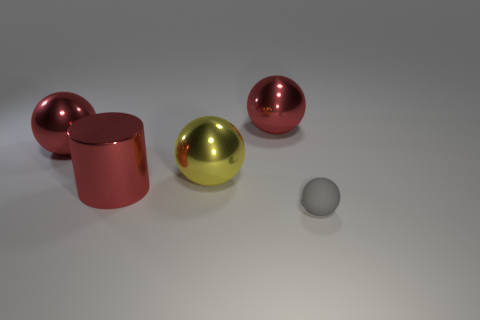Is there any other thing that is made of the same material as the small gray ball?
Offer a terse response. No. Are there any things that are in front of the thing behind the metallic thing that is to the left of the red metallic cylinder?
Keep it short and to the point. Yes. There is a yellow object that is the same size as the red shiny cylinder; what is its shape?
Give a very brief answer. Sphere. The other tiny object that is the same shape as the yellow metal object is what color?
Offer a very short reply. Gray. How many objects are either red balls or gray spheres?
Make the answer very short. 3. Do the large metal object that is right of the yellow shiny sphere and the thing that is to the left of the large cylinder have the same shape?
Offer a very short reply. Yes. There is a red metal thing that is in front of the yellow sphere; what shape is it?
Provide a short and direct response. Cylinder. Are there the same number of tiny objects in front of the yellow sphere and yellow things that are on the left side of the cylinder?
Give a very brief answer. No. How many things are tiny rubber balls or things that are on the left side of the red cylinder?
Ensure brevity in your answer.  2. The object that is in front of the yellow metal object and on the left side of the gray matte object has what shape?
Your answer should be very brief. Cylinder. 